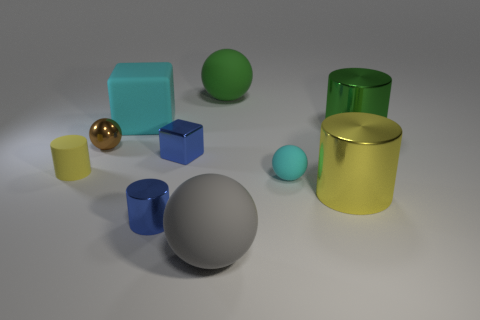What material is the object that is the same color as the rubber block?
Your answer should be very brief. Rubber. There is a green thing that is behind the big green cylinder behind the ball that is to the left of the gray matte sphere; how big is it?
Ensure brevity in your answer.  Large. There is a cyan object that is the same size as the brown shiny sphere; what is its material?
Give a very brief answer. Rubber. Is there another cyan rubber cylinder of the same size as the rubber cylinder?
Offer a very short reply. No. Does the small cyan thing have the same shape as the big cyan matte object?
Provide a short and direct response. No. There is a cyan matte thing that is right of the big rubber ball left of the large green rubber sphere; are there any large yellow metallic objects that are behind it?
Make the answer very short. No. What number of other objects are there of the same color as the rubber block?
Your answer should be very brief. 1. There is a rubber ball behind the brown object; is it the same size as the cyan thing that is left of the tiny blue metallic cylinder?
Keep it short and to the point. Yes. Are there an equal number of big cyan matte cubes behind the big green rubber object and metallic spheres that are to the right of the yellow metallic cylinder?
Offer a terse response. Yes. Is there any other thing that is made of the same material as the tiny cyan sphere?
Ensure brevity in your answer.  Yes. 